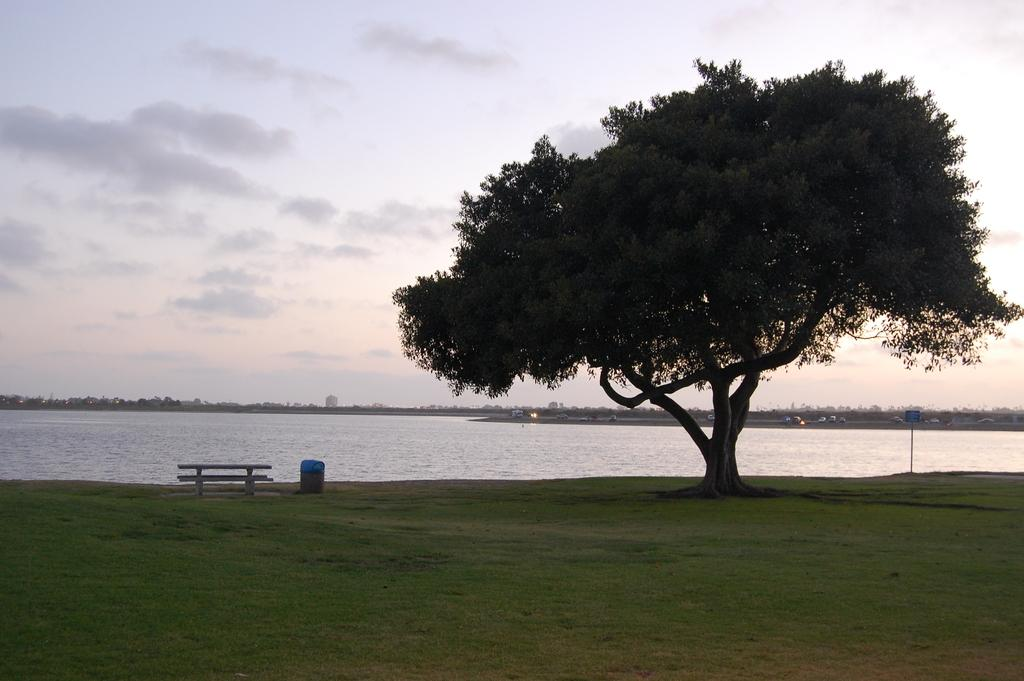What type of outdoor furniture is present in the image? There is a bench in the image. What other object can be seen in the image, besides the bench? There is a bin and a sign board in the image. Where are the bench, bin, and sign board located? The bench, bin, and sign board are on the grass in the image. What type of vegetation is visible in the image? There are trees in the image. What else can be seen in the image? There are vehicles, buildings, clouds in the sky, and water visible in the image. How many pizzas are being served on the bench in the image? There are no pizzas present in the image. Can you describe the behavior of the goose near the bin in the image? There is no goose present in the image. 